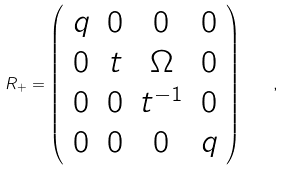<formula> <loc_0><loc_0><loc_500><loc_500>R _ { + } = \left ( \begin{array} { c c c c } q & 0 & 0 & 0 \\ 0 & t & \Omega & 0 \\ 0 & 0 & t ^ { - 1 } & 0 \\ 0 & 0 & 0 & q \end{array} \right ) \quad ,</formula> 